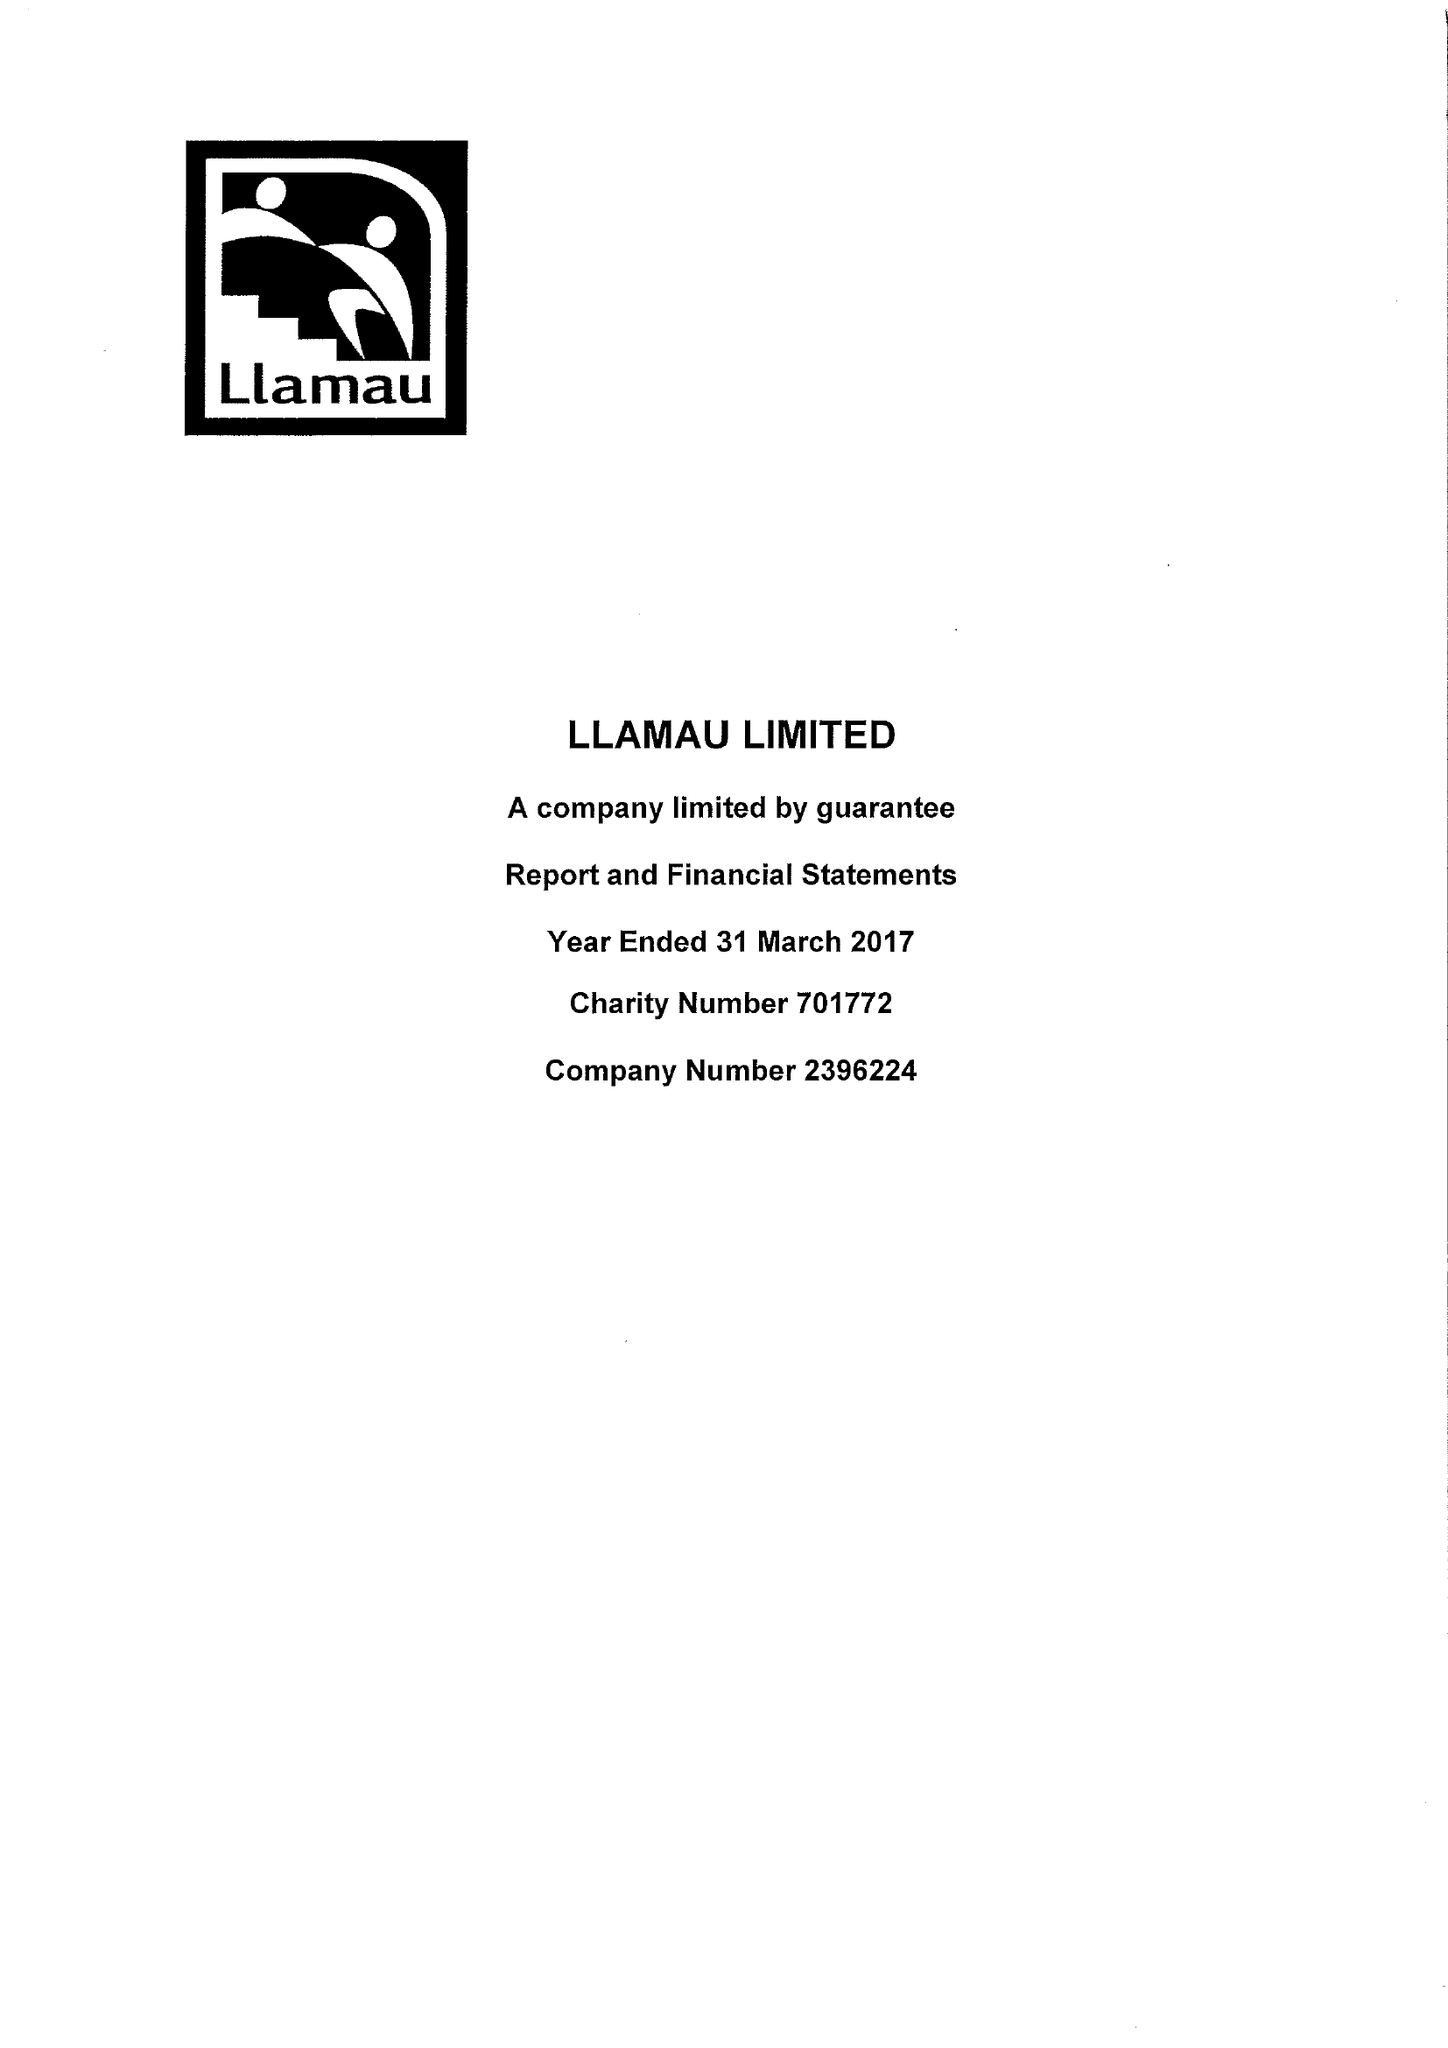What is the value for the address__postcode?
Answer the question using a single word or phrase. CF11 9HA 